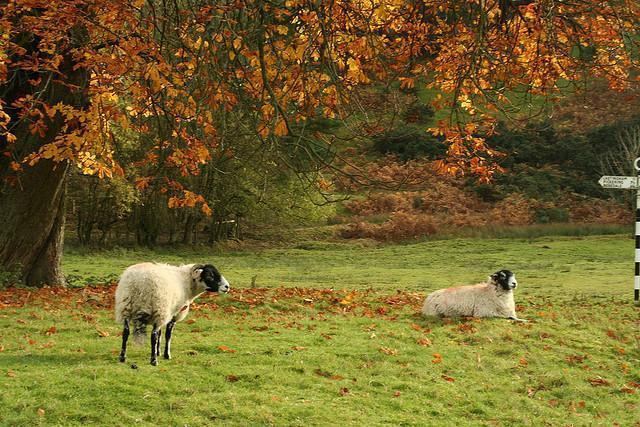How many sheep can you see?
Give a very brief answer. 2. 